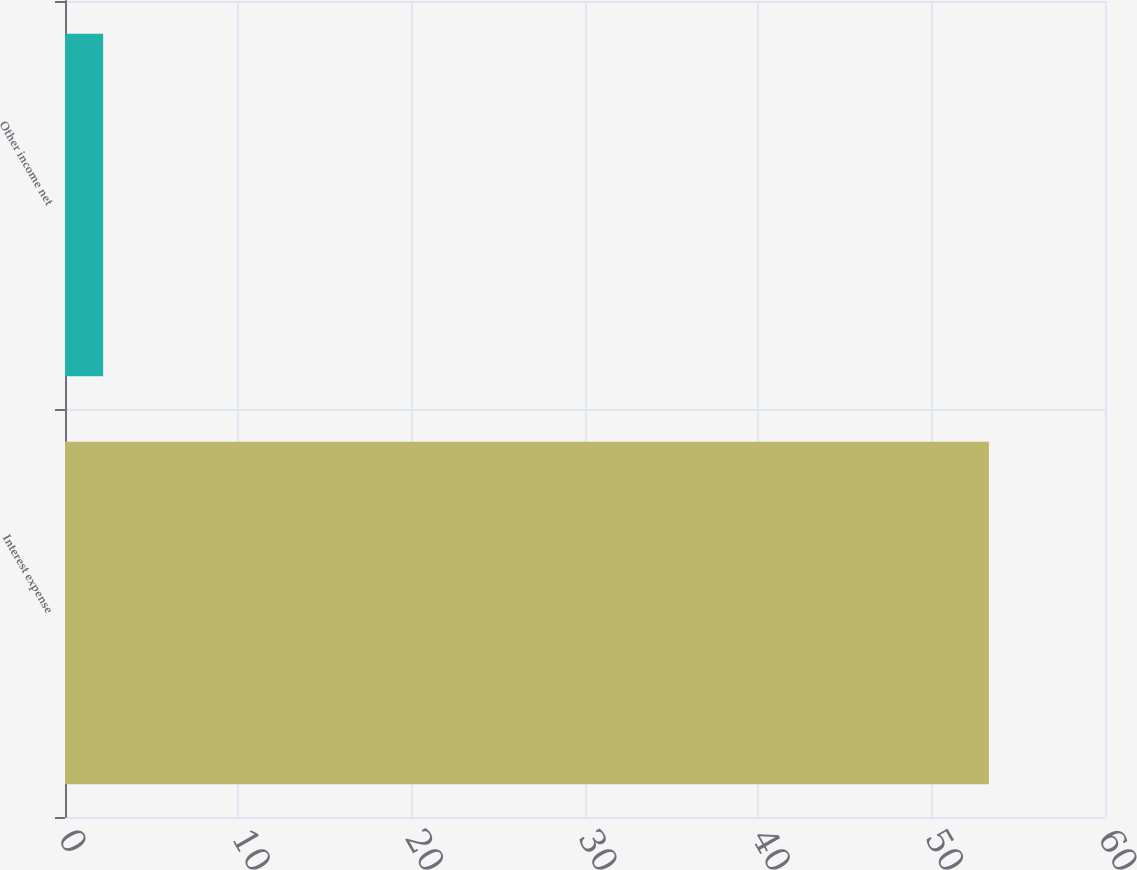<chart> <loc_0><loc_0><loc_500><loc_500><bar_chart><fcel>Interest expense<fcel>Other income net<nl><fcel>53.3<fcel>2.2<nl></chart> 